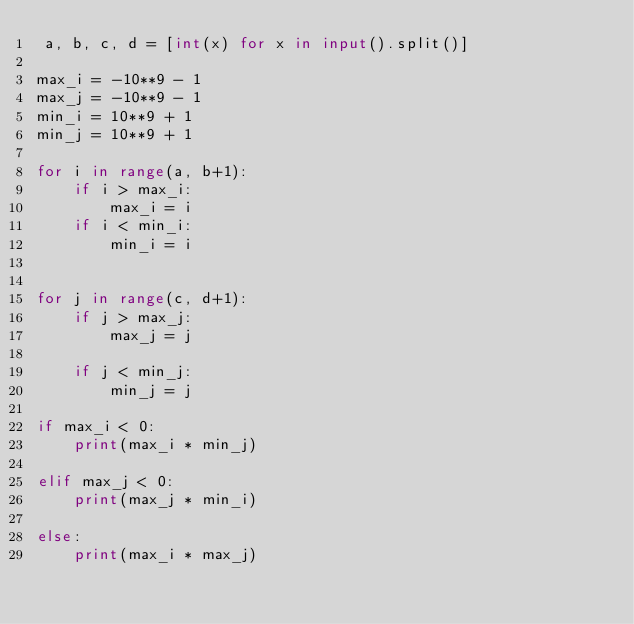<code> <loc_0><loc_0><loc_500><loc_500><_Python_> a, b, c, d = [int(x) for x in input().split()]

max_i = -10**9 - 1
max_j = -10**9 - 1
min_i = 10**9 + 1
min_j = 10**9 + 1

for i in range(a, b+1):
    if i > max_i:
        max_i = i
    if i < min_i:
        min_i = i


for j in range(c, d+1):
    if j > max_j:
        max_j = j

    if j < min_j:
        min_j = j

if max_i < 0:
    print(max_i * min_j)

elif max_j < 0:
    print(max_j * min_i)

else:
    print(max_i * max_j)
</code> 